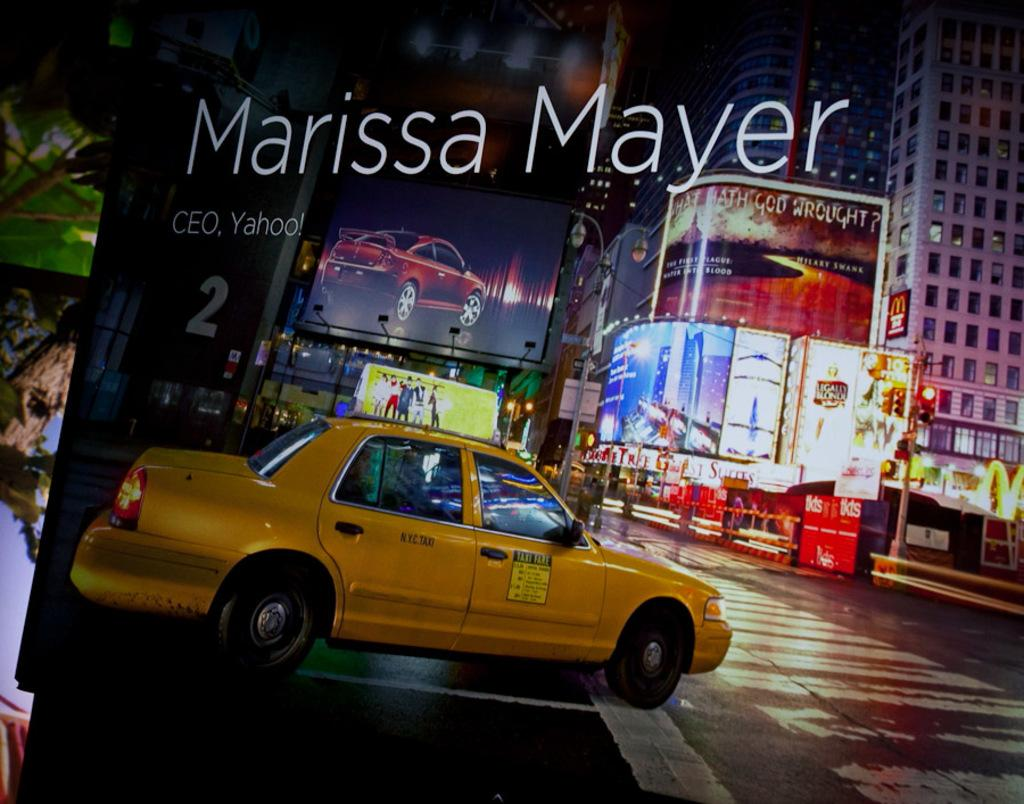<image>
Describe the image concisely. A poster for Marissa Mayer, CEO of Yahoo 